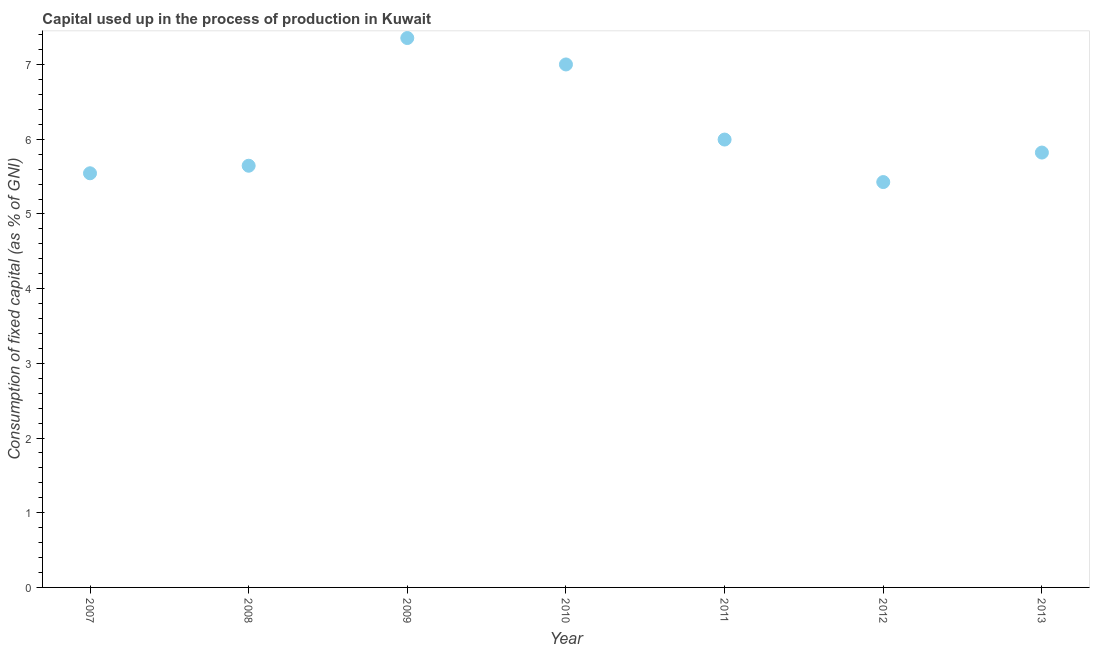What is the consumption of fixed capital in 2007?
Your response must be concise. 5.55. Across all years, what is the maximum consumption of fixed capital?
Offer a very short reply. 7.36. Across all years, what is the minimum consumption of fixed capital?
Ensure brevity in your answer.  5.43. In which year was the consumption of fixed capital maximum?
Keep it short and to the point. 2009. What is the sum of the consumption of fixed capital?
Your response must be concise. 42.8. What is the difference between the consumption of fixed capital in 2012 and 2013?
Provide a short and direct response. -0.4. What is the average consumption of fixed capital per year?
Ensure brevity in your answer.  6.11. What is the median consumption of fixed capital?
Provide a short and direct response. 5.82. In how many years, is the consumption of fixed capital greater than 4.2 %?
Offer a very short reply. 7. Do a majority of the years between 2013 and 2007 (inclusive) have consumption of fixed capital greater than 1.6 %?
Your answer should be very brief. Yes. What is the ratio of the consumption of fixed capital in 2007 to that in 2008?
Provide a succinct answer. 0.98. Is the consumption of fixed capital in 2007 less than that in 2013?
Your answer should be very brief. Yes. Is the difference between the consumption of fixed capital in 2007 and 2009 greater than the difference between any two years?
Offer a terse response. No. What is the difference between the highest and the second highest consumption of fixed capital?
Your answer should be very brief. 0.35. What is the difference between the highest and the lowest consumption of fixed capital?
Ensure brevity in your answer.  1.93. Does the consumption of fixed capital monotonically increase over the years?
Offer a very short reply. No. How many dotlines are there?
Provide a succinct answer. 1. Are the values on the major ticks of Y-axis written in scientific E-notation?
Your answer should be compact. No. Does the graph contain any zero values?
Keep it short and to the point. No. What is the title of the graph?
Ensure brevity in your answer.  Capital used up in the process of production in Kuwait. What is the label or title of the X-axis?
Your response must be concise. Year. What is the label or title of the Y-axis?
Provide a short and direct response. Consumption of fixed capital (as % of GNI). What is the Consumption of fixed capital (as % of GNI) in 2007?
Provide a succinct answer. 5.55. What is the Consumption of fixed capital (as % of GNI) in 2008?
Your answer should be very brief. 5.65. What is the Consumption of fixed capital (as % of GNI) in 2009?
Keep it short and to the point. 7.36. What is the Consumption of fixed capital (as % of GNI) in 2010?
Ensure brevity in your answer.  7. What is the Consumption of fixed capital (as % of GNI) in 2011?
Provide a succinct answer. 6. What is the Consumption of fixed capital (as % of GNI) in 2012?
Offer a terse response. 5.43. What is the Consumption of fixed capital (as % of GNI) in 2013?
Your answer should be compact. 5.82. What is the difference between the Consumption of fixed capital (as % of GNI) in 2007 and 2008?
Offer a terse response. -0.1. What is the difference between the Consumption of fixed capital (as % of GNI) in 2007 and 2009?
Make the answer very short. -1.81. What is the difference between the Consumption of fixed capital (as % of GNI) in 2007 and 2010?
Offer a terse response. -1.46. What is the difference between the Consumption of fixed capital (as % of GNI) in 2007 and 2011?
Ensure brevity in your answer.  -0.45. What is the difference between the Consumption of fixed capital (as % of GNI) in 2007 and 2012?
Make the answer very short. 0.12. What is the difference between the Consumption of fixed capital (as % of GNI) in 2007 and 2013?
Keep it short and to the point. -0.28. What is the difference between the Consumption of fixed capital (as % of GNI) in 2008 and 2009?
Offer a very short reply. -1.71. What is the difference between the Consumption of fixed capital (as % of GNI) in 2008 and 2010?
Make the answer very short. -1.36. What is the difference between the Consumption of fixed capital (as % of GNI) in 2008 and 2011?
Ensure brevity in your answer.  -0.35. What is the difference between the Consumption of fixed capital (as % of GNI) in 2008 and 2012?
Your answer should be very brief. 0.22. What is the difference between the Consumption of fixed capital (as % of GNI) in 2008 and 2013?
Give a very brief answer. -0.18. What is the difference between the Consumption of fixed capital (as % of GNI) in 2009 and 2010?
Offer a terse response. 0.35. What is the difference between the Consumption of fixed capital (as % of GNI) in 2009 and 2011?
Make the answer very short. 1.36. What is the difference between the Consumption of fixed capital (as % of GNI) in 2009 and 2012?
Your response must be concise. 1.93. What is the difference between the Consumption of fixed capital (as % of GNI) in 2009 and 2013?
Offer a terse response. 1.53. What is the difference between the Consumption of fixed capital (as % of GNI) in 2010 and 2011?
Provide a succinct answer. 1.01. What is the difference between the Consumption of fixed capital (as % of GNI) in 2010 and 2012?
Ensure brevity in your answer.  1.57. What is the difference between the Consumption of fixed capital (as % of GNI) in 2010 and 2013?
Offer a very short reply. 1.18. What is the difference between the Consumption of fixed capital (as % of GNI) in 2011 and 2012?
Your answer should be very brief. 0.57. What is the difference between the Consumption of fixed capital (as % of GNI) in 2011 and 2013?
Make the answer very short. 0.17. What is the difference between the Consumption of fixed capital (as % of GNI) in 2012 and 2013?
Offer a very short reply. -0.4. What is the ratio of the Consumption of fixed capital (as % of GNI) in 2007 to that in 2009?
Provide a short and direct response. 0.75. What is the ratio of the Consumption of fixed capital (as % of GNI) in 2007 to that in 2010?
Provide a short and direct response. 0.79. What is the ratio of the Consumption of fixed capital (as % of GNI) in 2007 to that in 2011?
Your answer should be compact. 0.93. What is the ratio of the Consumption of fixed capital (as % of GNI) in 2007 to that in 2012?
Provide a short and direct response. 1.02. What is the ratio of the Consumption of fixed capital (as % of GNI) in 2008 to that in 2009?
Your response must be concise. 0.77. What is the ratio of the Consumption of fixed capital (as % of GNI) in 2008 to that in 2010?
Provide a succinct answer. 0.81. What is the ratio of the Consumption of fixed capital (as % of GNI) in 2008 to that in 2011?
Ensure brevity in your answer.  0.94. What is the ratio of the Consumption of fixed capital (as % of GNI) in 2008 to that in 2012?
Your answer should be compact. 1.04. What is the ratio of the Consumption of fixed capital (as % of GNI) in 2008 to that in 2013?
Ensure brevity in your answer.  0.97. What is the ratio of the Consumption of fixed capital (as % of GNI) in 2009 to that in 2010?
Offer a terse response. 1.05. What is the ratio of the Consumption of fixed capital (as % of GNI) in 2009 to that in 2011?
Provide a short and direct response. 1.23. What is the ratio of the Consumption of fixed capital (as % of GNI) in 2009 to that in 2012?
Your answer should be compact. 1.35. What is the ratio of the Consumption of fixed capital (as % of GNI) in 2009 to that in 2013?
Your answer should be very brief. 1.26. What is the ratio of the Consumption of fixed capital (as % of GNI) in 2010 to that in 2011?
Your response must be concise. 1.17. What is the ratio of the Consumption of fixed capital (as % of GNI) in 2010 to that in 2012?
Offer a very short reply. 1.29. What is the ratio of the Consumption of fixed capital (as % of GNI) in 2010 to that in 2013?
Provide a succinct answer. 1.2. What is the ratio of the Consumption of fixed capital (as % of GNI) in 2011 to that in 2012?
Make the answer very short. 1.1. What is the ratio of the Consumption of fixed capital (as % of GNI) in 2011 to that in 2013?
Make the answer very short. 1.03. What is the ratio of the Consumption of fixed capital (as % of GNI) in 2012 to that in 2013?
Offer a terse response. 0.93. 